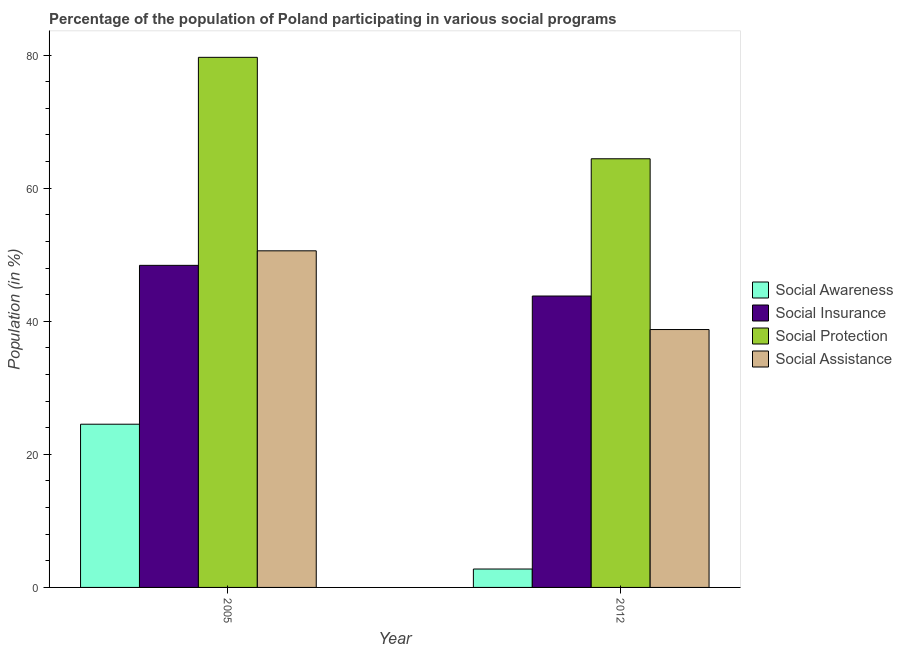How many groups of bars are there?
Ensure brevity in your answer.  2. How many bars are there on the 2nd tick from the right?
Your answer should be compact. 4. What is the label of the 1st group of bars from the left?
Give a very brief answer. 2005. In how many cases, is the number of bars for a given year not equal to the number of legend labels?
Your answer should be very brief. 0. What is the participation of population in social protection programs in 2012?
Keep it short and to the point. 64.41. Across all years, what is the maximum participation of population in social assistance programs?
Ensure brevity in your answer.  50.58. Across all years, what is the minimum participation of population in social assistance programs?
Make the answer very short. 38.75. In which year was the participation of population in social awareness programs maximum?
Your answer should be very brief. 2005. In which year was the participation of population in social protection programs minimum?
Provide a succinct answer. 2012. What is the total participation of population in social assistance programs in the graph?
Your answer should be compact. 89.34. What is the difference between the participation of population in social awareness programs in 2005 and that in 2012?
Offer a terse response. 21.76. What is the difference between the participation of population in social assistance programs in 2005 and the participation of population in social protection programs in 2012?
Keep it short and to the point. 11.83. What is the average participation of population in social awareness programs per year?
Your answer should be very brief. 13.65. What is the ratio of the participation of population in social insurance programs in 2005 to that in 2012?
Your answer should be very brief. 1.11. Is the participation of population in social protection programs in 2005 less than that in 2012?
Make the answer very short. No. What does the 3rd bar from the left in 2012 represents?
Your response must be concise. Social Protection. What does the 2nd bar from the right in 2005 represents?
Offer a terse response. Social Protection. How many years are there in the graph?
Provide a short and direct response. 2. Does the graph contain any zero values?
Provide a succinct answer. No. Does the graph contain grids?
Ensure brevity in your answer.  No. How are the legend labels stacked?
Your answer should be very brief. Vertical. What is the title of the graph?
Make the answer very short. Percentage of the population of Poland participating in various social programs . Does "Structural Policies" appear as one of the legend labels in the graph?
Offer a terse response. No. What is the label or title of the X-axis?
Ensure brevity in your answer.  Year. What is the label or title of the Y-axis?
Keep it short and to the point. Population (in %). What is the Population (in %) in Social Awareness in 2005?
Your answer should be very brief. 24.53. What is the Population (in %) of Social Insurance in 2005?
Make the answer very short. 48.4. What is the Population (in %) of Social Protection in 2005?
Provide a succinct answer. 79.66. What is the Population (in %) in Social Assistance in 2005?
Your answer should be very brief. 50.58. What is the Population (in %) in Social Awareness in 2012?
Your answer should be very brief. 2.77. What is the Population (in %) in Social Insurance in 2012?
Offer a terse response. 43.79. What is the Population (in %) in Social Protection in 2012?
Your answer should be very brief. 64.41. What is the Population (in %) of Social Assistance in 2012?
Keep it short and to the point. 38.75. Across all years, what is the maximum Population (in %) of Social Awareness?
Your answer should be compact. 24.53. Across all years, what is the maximum Population (in %) of Social Insurance?
Ensure brevity in your answer.  48.4. Across all years, what is the maximum Population (in %) in Social Protection?
Make the answer very short. 79.66. Across all years, what is the maximum Population (in %) of Social Assistance?
Your response must be concise. 50.58. Across all years, what is the minimum Population (in %) of Social Awareness?
Ensure brevity in your answer.  2.77. Across all years, what is the minimum Population (in %) in Social Insurance?
Keep it short and to the point. 43.79. Across all years, what is the minimum Population (in %) of Social Protection?
Make the answer very short. 64.41. Across all years, what is the minimum Population (in %) in Social Assistance?
Make the answer very short. 38.75. What is the total Population (in %) of Social Awareness in the graph?
Offer a very short reply. 27.29. What is the total Population (in %) in Social Insurance in the graph?
Make the answer very short. 92.19. What is the total Population (in %) of Social Protection in the graph?
Your answer should be very brief. 144.07. What is the total Population (in %) in Social Assistance in the graph?
Provide a succinct answer. 89.34. What is the difference between the Population (in %) in Social Awareness in 2005 and that in 2012?
Provide a short and direct response. 21.76. What is the difference between the Population (in %) in Social Insurance in 2005 and that in 2012?
Keep it short and to the point. 4.61. What is the difference between the Population (in %) in Social Protection in 2005 and that in 2012?
Your answer should be very brief. 15.24. What is the difference between the Population (in %) of Social Assistance in 2005 and that in 2012?
Keep it short and to the point. 11.83. What is the difference between the Population (in %) in Social Awareness in 2005 and the Population (in %) in Social Insurance in 2012?
Keep it short and to the point. -19.26. What is the difference between the Population (in %) in Social Awareness in 2005 and the Population (in %) in Social Protection in 2012?
Ensure brevity in your answer.  -39.89. What is the difference between the Population (in %) of Social Awareness in 2005 and the Population (in %) of Social Assistance in 2012?
Provide a succinct answer. -14.23. What is the difference between the Population (in %) of Social Insurance in 2005 and the Population (in %) of Social Protection in 2012?
Ensure brevity in your answer.  -16.02. What is the difference between the Population (in %) of Social Insurance in 2005 and the Population (in %) of Social Assistance in 2012?
Keep it short and to the point. 9.65. What is the difference between the Population (in %) of Social Protection in 2005 and the Population (in %) of Social Assistance in 2012?
Your answer should be compact. 40.91. What is the average Population (in %) in Social Awareness per year?
Offer a very short reply. 13.65. What is the average Population (in %) of Social Insurance per year?
Offer a terse response. 46.09. What is the average Population (in %) in Social Protection per year?
Give a very brief answer. 72.04. What is the average Population (in %) in Social Assistance per year?
Make the answer very short. 44.67. In the year 2005, what is the difference between the Population (in %) in Social Awareness and Population (in %) in Social Insurance?
Give a very brief answer. -23.87. In the year 2005, what is the difference between the Population (in %) in Social Awareness and Population (in %) in Social Protection?
Offer a very short reply. -55.13. In the year 2005, what is the difference between the Population (in %) in Social Awareness and Population (in %) in Social Assistance?
Provide a short and direct response. -26.06. In the year 2005, what is the difference between the Population (in %) in Social Insurance and Population (in %) in Social Protection?
Ensure brevity in your answer.  -31.26. In the year 2005, what is the difference between the Population (in %) of Social Insurance and Population (in %) of Social Assistance?
Your answer should be compact. -2.18. In the year 2005, what is the difference between the Population (in %) of Social Protection and Population (in %) of Social Assistance?
Your answer should be very brief. 29.08. In the year 2012, what is the difference between the Population (in %) in Social Awareness and Population (in %) in Social Insurance?
Give a very brief answer. -41.02. In the year 2012, what is the difference between the Population (in %) in Social Awareness and Population (in %) in Social Protection?
Offer a very short reply. -61.65. In the year 2012, what is the difference between the Population (in %) of Social Awareness and Population (in %) of Social Assistance?
Your answer should be compact. -35.99. In the year 2012, what is the difference between the Population (in %) of Social Insurance and Population (in %) of Social Protection?
Give a very brief answer. -20.63. In the year 2012, what is the difference between the Population (in %) in Social Insurance and Population (in %) in Social Assistance?
Offer a terse response. 5.04. In the year 2012, what is the difference between the Population (in %) of Social Protection and Population (in %) of Social Assistance?
Ensure brevity in your answer.  25.66. What is the ratio of the Population (in %) of Social Awareness in 2005 to that in 2012?
Offer a very short reply. 8.87. What is the ratio of the Population (in %) of Social Insurance in 2005 to that in 2012?
Keep it short and to the point. 1.11. What is the ratio of the Population (in %) of Social Protection in 2005 to that in 2012?
Give a very brief answer. 1.24. What is the ratio of the Population (in %) of Social Assistance in 2005 to that in 2012?
Keep it short and to the point. 1.31. What is the difference between the highest and the second highest Population (in %) in Social Awareness?
Give a very brief answer. 21.76. What is the difference between the highest and the second highest Population (in %) in Social Insurance?
Keep it short and to the point. 4.61. What is the difference between the highest and the second highest Population (in %) of Social Protection?
Provide a succinct answer. 15.24. What is the difference between the highest and the second highest Population (in %) in Social Assistance?
Give a very brief answer. 11.83. What is the difference between the highest and the lowest Population (in %) of Social Awareness?
Your answer should be very brief. 21.76. What is the difference between the highest and the lowest Population (in %) of Social Insurance?
Make the answer very short. 4.61. What is the difference between the highest and the lowest Population (in %) in Social Protection?
Keep it short and to the point. 15.24. What is the difference between the highest and the lowest Population (in %) of Social Assistance?
Offer a terse response. 11.83. 